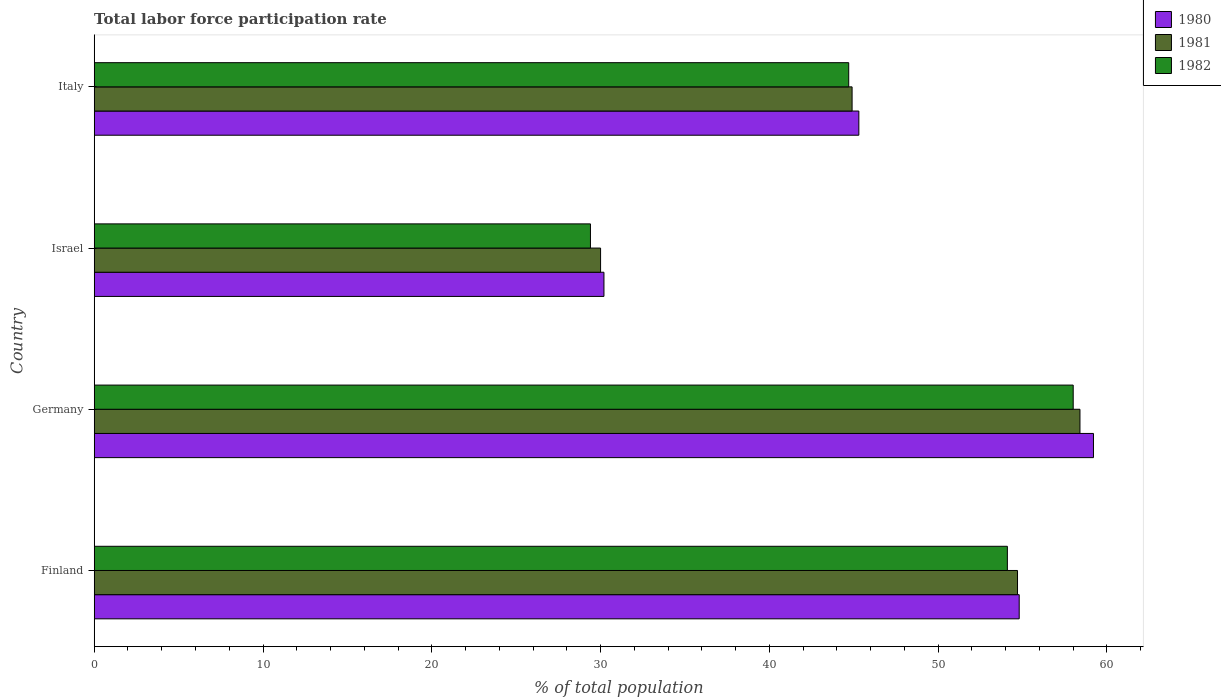How many groups of bars are there?
Ensure brevity in your answer.  4. Are the number of bars on each tick of the Y-axis equal?
Keep it short and to the point. Yes. In how many cases, is the number of bars for a given country not equal to the number of legend labels?
Your response must be concise. 0. What is the total labor force participation rate in 1981 in Israel?
Make the answer very short. 30. Across all countries, what is the minimum total labor force participation rate in 1982?
Your answer should be very brief. 29.4. In which country was the total labor force participation rate in 1982 maximum?
Make the answer very short. Germany. In which country was the total labor force participation rate in 1980 minimum?
Your response must be concise. Israel. What is the total total labor force participation rate in 1980 in the graph?
Offer a very short reply. 189.5. What is the difference between the total labor force participation rate in 1982 in Germany and that in Italy?
Your response must be concise. 13.3. What is the difference between the total labor force participation rate in 1982 in Israel and the total labor force participation rate in 1981 in Germany?
Keep it short and to the point. -29. What is the average total labor force participation rate in 1981 per country?
Ensure brevity in your answer.  47. What is the difference between the total labor force participation rate in 1981 and total labor force participation rate in 1980 in Germany?
Keep it short and to the point. -0.8. What is the ratio of the total labor force participation rate in 1982 in Germany to that in Italy?
Give a very brief answer. 1.3. Is the difference between the total labor force participation rate in 1981 in Germany and Italy greater than the difference between the total labor force participation rate in 1980 in Germany and Italy?
Your answer should be compact. No. What is the difference between the highest and the second highest total labor force participation rate in 1980?
Make the answer very short. 4.4. What is the difference between the highest and the lowest total labor force participation rate in 1981?
Your answer should be compact. 28.4. Is the sum of the total labor force participation rate in 1980 in Finland and Italy greater than the maximum total labor force participation rate in 1981 across all countries?
Your answer should be compact. Yes. What does the 3rd bar from the top in Finland represents?
Make the answer very short. 1980. Is it the case that in every country, the sum of the total labor force participation rate in 1982 and total labor force participation rate in 1980 is greater than the total labor force participation rate in 1981?
Offer a terse response. Yes. How many countries are there in the graph?
Ensure brevity in your answer.  4. What is the difference between two consecutive major ticks on the X-axis?
Provide a short and direct response. 10. Are the values on the major ticks of X-axis written in scientific E-notation?
Keep it short and to the point. No. How are the legend labels stacked?
Make the answer very short. Vertical. What is the title of the graph?
Make the answer very short. Total labor force participation rate. Does "1984" appear as one of the legend labels in the graph?
Your answer should be very brief. No. What is the label or title of the X-axis?
Your answer should be compact. % of total population. What is the label or title of the Y-axis?
Make the answer very short. Country. What is the % of total population in 1980 in Finland?
Your response must be concise. 54.8. What is the % of total population of 1981 in Finland?
Keep it short and to the point. 54.7. What is the % of total population in 1982 in Finland?
Your answer should be very brief. 54.1. What is the % of total population of 1980 in Germany?
Your answer should be compact. 59.2. What is the % of total population of 1981 in Germany?
Your answer should be very brief. 58.4. What is the % of total population of 1982 in Germany?
Your answer should be compact. 58. What is the % of total population in 1980 in Israel?
Make the answer very short. 30.2. What is the % of total population in 1981 in Israel?
Keep it short and to the point. 30. What is the % of total population of 1982 in Israel?
Offer a very short reply. 29.4. What is the % of total population of 1980 in Italy?
Keep it short and to the point. 45.3. What is the % of total population in 1981 in Italy?
Keep it short and to the point. 44.9. What is the % of total population in 1982 in Italy?
Keep it short and to the point. 44.7. Across all countries, what is the maximum % of total population in 1980?
Give a very brief answer. 59.2. Across all countries, what is the maximum % of total population in 1981?
Offer a very short reply. 58.4. Across all countries, what is the minimum % of total population in 1980?
Offer a very short reply. 30.2. Across all countries, what is the minimum % of total population of 1981?
Provide a short and direct response. 30. Across all countries, what is the minimum % of total population of 1982?
Your answer should be compact. 29.4. What is the total % of total population in 1980 in the graph?
Give a very brief answer. 189.5. What is the total % of total population of 1981 in the graph?
Offer a terse response. 188. What is the total % of total population in 1982 in the graph?
Make the answer very short. 186.2. What is the difference between the % of total population of 1980 in Finland and that in Germany?
Keep it short and to the point. -4.4. What is the difference between the % of total population in 1981 in Finland and that in Germany?
Provide a short and direct response. -3.7. What is the difference between the % of total population in 1980 in Finland and that in Israel?
Your answer should be compact. 24.6. What is the difference between the % of total population of 1981 in Finland and that in Israel?
Keep it short and to the point. 24.7. What is the difference between the % of total population of 1982 in Finland and that in Israel?
Your answer should be very brief. 24.7. What is the difference between the % of total population in 1980 in Finland and that in Italy?
Make the answer very short. 9.5. What is the difference between the % of total population in 1980 in Germany and that in Israel?
Keep it short and to the point. 29. What is the difference between the % of total population of 1981 in Germany and that in Israel?
Give a very brief answer. 28.4. What is the difference between the % of total population of 1982 in Germany and that in Israel?
Offer a very short reply. 28.6. What is the difference between the % of total population in 1982 in Germany and that in Italy?
Offer a very short reply. 13.3. What is the difference between the % of total population in 1980 in Israel and that in Italy?
Ensure brevity in your answer.  -15.1. What is the difference between the % of total population of 1981 in Israel and that in Italy?
Make the answer very short. -14.9. What is the difference between the % of total population of 1982 in Israel and that in Italy?
Provide a short and direct response. -15.3. What is the difference between the % of total population of 1980 in Finland and the % of total population of 1981 in Germany?
Provide a short and direct response. -3.6. What is the difference between the % of total population of 1980 in Finland and the % of total population of 1982 in Germany?
Keep it short and to the point. -3.2. What is the difference between the % of total population of 1981 in Finland and the % of total population of 1982 in Germany?
Your answer should be compact. -3.3. What is the difference between the % of total population in 1980 in Finland and the % of total population in 1981 in Israel?
Ensure brevity in your answer.  24.8. What is the difference between the % of total population in 1980 in Finland and the % of total population in 1982 in Israel?
Your answer should be very brief. 25.4. What is the difference between the % of total population in 1981 in Finland and the % of total population in 1982 in Israel?
Offer a terse response. 25.3. What is the difference between the % of total population of 1980 in Finland and the % of total population of 1982 in Italy?
Your answer should be very brief. 10.1. What is the difference between the % of total population in 1980 in Germany and the % of total population in 1981 in Israel?
Ensure brevity in your answer.  29.2. What is the difference between the % of total population in 1980 in Germany and the % of total population in 1982 in Israel?
Provide a succinct answer. 29.8. What is the difference between the % of total population in 1980 in Germany and the % of total population in 1981 in Italy?
Your response must be concise. 14.3. What is the difference between the % of total population of 1980 in Germany and the % of total population of 1982 in Italy?
Make the answer very short. 14.5. What is the difference between the % of total population in 1980 in Israel and the % of total population in 1981 in Italy?
Your response must be concise. -14.7. What is the difference between the % of total population in 1981 in Israel and the % of total population in 1982 in Italy?
Provide a succinct answer. -14.7. What is the average % of total population of 1980 per country?
Provide a succinct answer. 47.38. What is the average % of total population in 1982 per country?
Ensure brevity in your answer.  46.55. What is the difference between the % of total population in 1980 and % of total population in 1981 in Finland?
Keep it short and to the point. 0.1. What is the difference between the % of total population in 1980 and % of total population in 1982 in Finland?
Your response must be concise. 0.7. What is the difference between the % of total population in 1980 and % of total population in 1981 in Germany?
Ensure brevity in your answer.  0.8. What is the difference between the % of total population in 1980 and % of total population in 1982 in Germany?
Give a very brief answer. 1.2. What is the difference between the % of total population in 1980 and % of total population in 1981 in Israel?
Give a very brief answer. 0.2. What is the difference between the % of total population of 1980 and % of total population of 1981 in Italy?
Your response must be concise. 0.4. What is the ratio of the % of total population of 1980 in Finland to that in Germany?
Your answer should be compact. 0.93. What is the ratio of the % of total population of 1981 in Finland to that in Germany?
Provide a short and direct response. 0.94. What is the ratio of the % of total population in 1982 in Finland to that in Germany?
Ensure brevity in your answer.  0.93. What is the ratio of the % of total population of 1980 in Finland to that in Israel?
Give a very brief answer. 1.81. What is the ratio of the % of total population of 1981 in Finland to that in Israel?
Offer a terse response. 1.82. What is the ratio of the % of total population in 1982 in Finland to that in Israel?
Provide a succinct answer. 1.84. What is the ratio of the % of total population in 1980 in Finland to that in Italy?
Keep it short and to the point. 1.21. What is the ratio of the % of total population of 1981 in Finland to that in Italy?
Make the answer very short. 1.22. What is the ratio of the % of total population of 1982 in Finland to that in Italy?
Make the answer very short. 1.21. What is the ratio of the % of total population of 1980 in Germany to that in Israel?
Ensure brevity in your answer.  1.96. What is the ratio of the % of total population in 1981 in Germany to that in Israel?
Keep it short and to the point. 1.95. What is the ratio of the % of total population in 1982 in Germany to that in Israel?
Your answer should be compact. 1.97. What is the ratio of the % of total population of 1980 in Germany to that in Italy?
Make the answer very short. 1.31. What is the ratio of the % of total population in 1981 in Germany to that in Italy?
Give a very brief answer. 1.3. What is the ratio of the % of total population in 1982 in Germany to that in Italy?
Keep it short and to the point. 1.3. What is the ratio of the % of total population in 1980 in Israel to that in Italy?
Ensure brevity in your answer.  0.67. What is the ratio of the % of total population of 1981 in Israel to that in Italy?
Your answer should be compact. 0.67. What is the ratio of the % of total population in 1982 in Israel to that in Italy?
Your answer should be very brief. 0.66. What is the difference between the highest and the second highest % of total population of 1980?
Provide a short and direct response. 4.4. What is the difference between the highest and the second highest % of total population in 1981?
Make the answer very short. 3.7. What is the difference between the highest and the second highest % of total population in 1982?
Your answer should be very brief. 3.9. What is the difference between the highest and the lowest % of total population in 1981?
Keep it short and to the point. 28.4. What is the difference between the highest and the lowest % of total population of 1982?
Offer a very short reply. 28.6. 